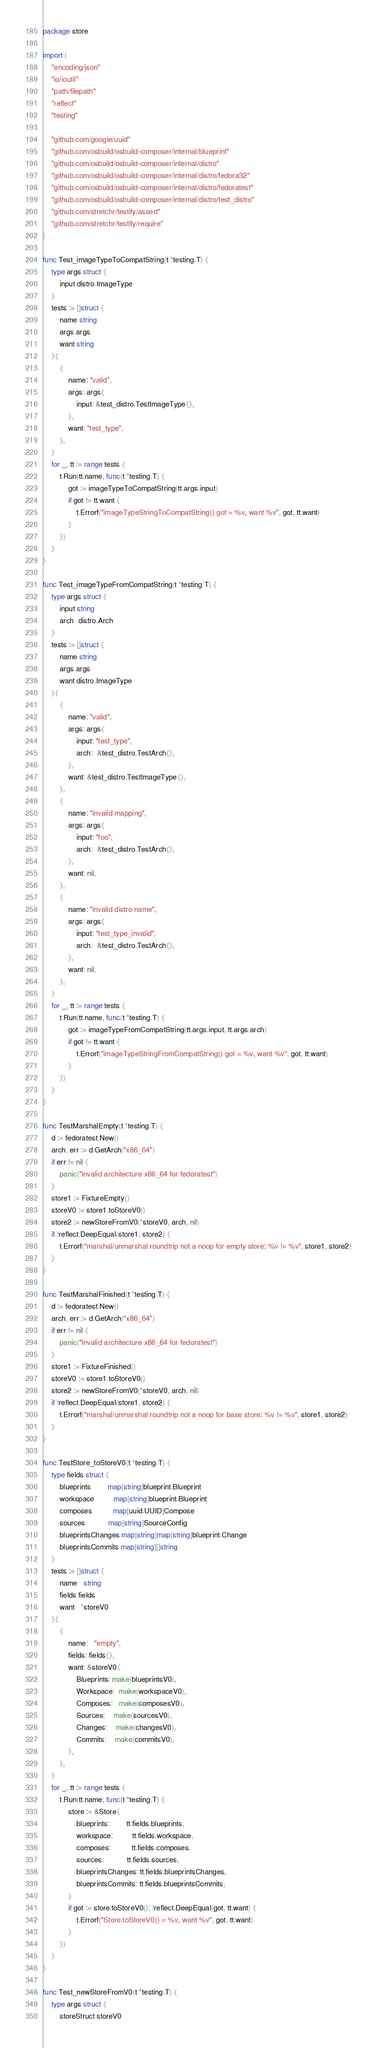<code> <loc_0><loc_0><loc_500><loc_500><_Go_>package store

import (
	"encoding/json"
	"io/ioutil"
	"path/filepath"
	"reflect"
	"testing"

	"github.com/google/uuid"
	"github.com/osbuild/osbuild-composer/internal/blueprint"
	"github.com/osbuild/osbuild-composer/internal/distro"
	"github.com/osbuild/osbuild-composer/internal/distro/fedora32"
	"github.com/osbuild/osbuild-composer/internal/distro/fedoratest"
	"github.com/osbuild/osbuild-composer/internal/distro/test_distro"
	"github.com/stretchr/testify/assert"
	"github.com/stretchr/testify/require"
)

func Test_imageTypeToCompatString(t *testing.T) {
	type args struct {
		input distro.ImageType
	}
	tests := []struct {
		name string
		args args
		want string
	}{
		{
			name: "valid",
			args: args{
				input: &test_distro.TestImageType{},
			},
			want: "test_type",
		},
	}
	for _, tt := range tests {
		t.Run(tt.name, func(t *testing.T) {
			got := imageTypeToCompatString(tt.args.input)
			if got != tt.want {
				t.Errorf("imageTypeStringToCompatString() got = %v, want %v", got, tt.want)
			}
		})
	}
}

func Test_imageTypeFromCompatString(t *testing.T) {
	type args struct {
		input string
		arch  distro.Arch
	}
	tests := []struct {
		name string
		args args
		want distro.ImageType
	}{
		{
			name: "valid",
			args: args{
				input: "test_type",
				arch:  &test_distro.TestArch{},
			},
			want: &test_distro.TestImageType{},
		},
		{
			name: "invalid mapping",
			args: args{
				input: "foo",
				arch:  &test_distro.TestArch{},
			},
			want: nil,
		},
		{
			name: "invalid distro name",
			args: args{
				input: "test_type_invalid",
				arch:  &test_distro.TestArch{},
			},
			want: nil,
		},
	}
	for _, tt := range tests {
		t.Run(tt.name, func(t *testing.T) {
			got := imageTypeFromCompatString(tt.args.input, tt.args.arch)
			if got != tt.want {
				t.Errorf("imageTypeStringFromCompatString() got = %v, want %v", got, tt.want)
			}
		})
	}
}

func TestMarshalEmpty(t *testing.T) {
	d := fedoratest.New()
	arch, err := d.GetArch("x86_64")
	if err != nil {
		panic("invalid architecture x86_64 for fedoratest")
	}
	store1 := FixtureEmpty()
	storeV0 := store1.toStoreV0()
	store2 := newStoreFromV0(*storeV0, arch, nil)
	if !reflect.DeepEqual(store1, store2) {
		t.Errorf("marshal/unmarshal roundtrip not a noop for empty store: %v != %v", store1, store2)
	}
}

func TestMarshalFinished(t *testing.T) {
	d := fedoratest.New()
	arch, err := d.GetArch("x86_64")
	if err != nil {
		panic("invalid architecture x86_64 for fedoratest")
	}
	store1 := FixtureFinished()
	storeV0 := store1.toStoreV0()
	store2 := newStoreFromV0(*storeV0, arch, nil)
	if !reflect.DeepEqual(store1, store2) {
		t.Errorf("marshal/unmarshal roundtrip not a noop for base store: %v != %v", store1, store2)
	}
}

func TestStore_toStoreV0(t *testing.T) {
	type fields struct {
		blueprints        map[string]blueprint.Blueprint
		workspace         map[string]blueprint.Blueprint
		composes          map[uuid.UUID]Compose
		sources           map[string]SourceConfig
		blueprintsChanges map[string]map[string]blueprint.Change
		blueprintsCommits map[string][]string
	}
	tests := []struct {
		name   string
		fields fields
		want   *storeV0
	}{
		{
			name:   "empty",
			fields: fields{},
			want: &storeV0{
				Blueprints: make(blueprintsV0),
				Workspace:  make(workspaceV0),
				Composes:   make(composesV0),
				Sources:    make(sourcesV0),
				Changes:    make(changesV0),
				Commits:    make(commitsV0),
			},
		},
	}
	for _, tt := range tests {
		t.Run(tt.name, func(t *testing.T) {
			store := &Store{
				blueprints:        tt.fields.blueprints,
				workspace:         tt.fields.workspace,
				composes:          tt.fields.composes,
				sources:           tt.fields.sources,
				blueprintsChanges: tt.fields.blueprintsChanges,
				blueprintsCommits: tt.fields.blueprintsCommits,
			}
			if got := store.toStoreV0(); !reflect.DeepEqual(got, tt.want) {
				t.Errorf("Store.toStoreV0() = %v, want %v", got, tt.want)
			}
		})
	}
}

func Test_newStoreFromV0(t *testing.T) {
	type args struct {
		storeStruct storeV0</code> 